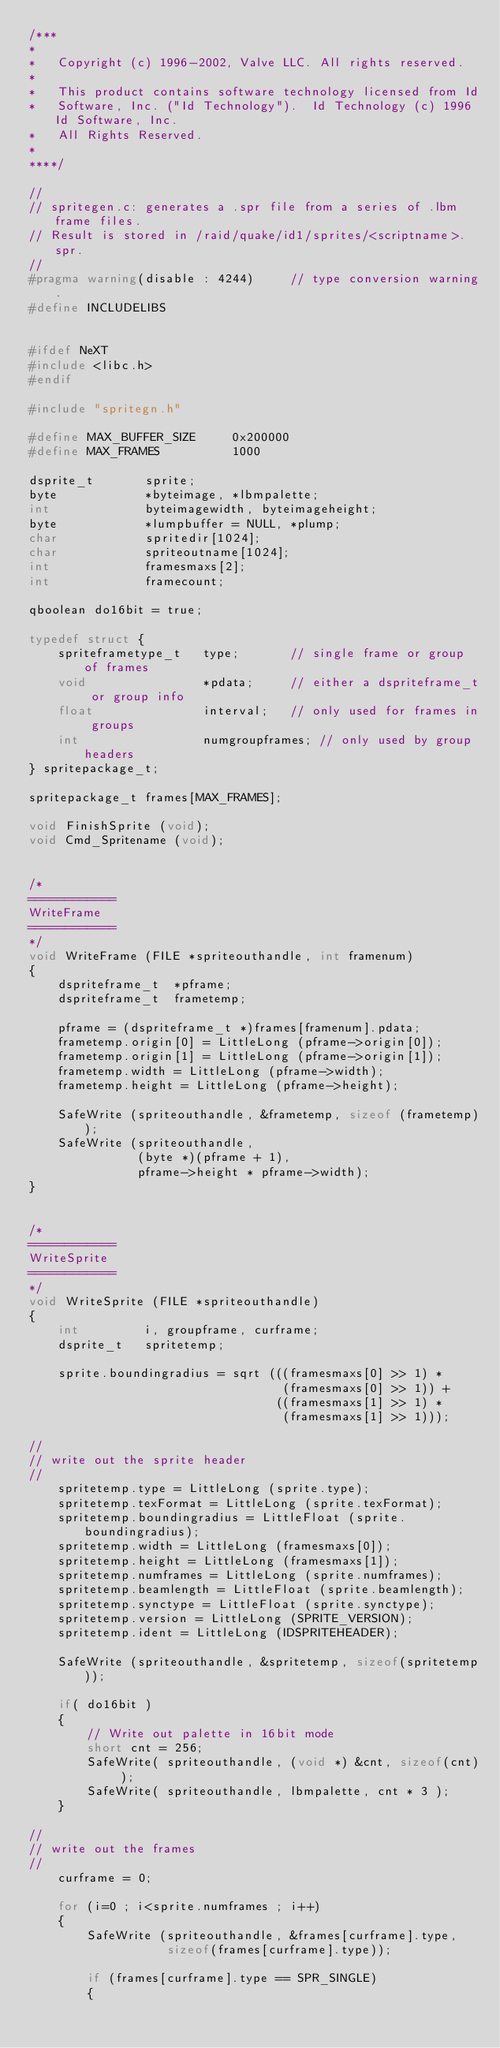<code> <loc_0><loc_0><loc_500><loc_500><_C_>/***
*
*	Copyright (c) 1996-2002, Valve LLC. All rights reserved.
*	
*	This product contains software technology licensed from Id 
*	Software, Inc. ("Id Technology").  Id Technology (c) 1996 Id Software, Inc. 
*	All Rights Reserved.
*
****/

//
// spritegen.c: generates a .spr file from a series of .lbm frame files.
// Result is stored in /raid/quake/id1/sprites/<scriptname>.spr.
//
#pragma warning(disable : 4244)     // type conversion warning.
#define INCLUDELIBS


#ifdef NeXT
#include <libc.h>
#endif

#include "spritegn.h"

#define MAX_BUFFER_SIZE		0x200000
#define MAX_FRAMES			1000

dsprite_t		sprite;
byte			*byteimage, *lbmpalette;
int				byteimagewidth, byteimageheight;
byte			*lumpbuffer = NULL, *plump;
char			spritedir[1024];
char			spriteoutname[1024];
int				framesmaxs[2];
int				framecount;

qboolean do16bit = true;

typedef struct {
	spriteframetype_t	type;		// single frame or group of frames
	void				*pdata;		// either a dspriteframe_t or group info
	float				interval;	// only used for frames in groups
	int					numgroupframes;	// only used by group headers
} spritepackage_t;

spritepackage_t	frames[MAX_FRAMES];

void FinishSprite (void);
void Cmd_Spritename (void);


/*
============
WriteFrame
============
*/
void WriteFrame (FILE *spriteouthandle, int framenum)
{
	dspriteframe_t	*pframe;
	dspriteframe_t	frametemp;

	pframe = (dspriteframe_t *)frames[framenum].pdata;
	frametemp.origin[0] = LittleLong (pframe->origin[0]);
	frametemp.origin[1] = LittleLong (pframe->origin[1]);
	frametemp.width = LittleLong (pframe->width);
	frametemp.height = LittleLong (pframe->height);

	SafeWrite (spriteouthandle, &frametemp, sizeof (frametemp));
	SafeWrite (spriteouthandle,
			   (byte *)(pframe + 1),
			   pframe->height * pframe->width);
}


/*
============
WriteSprite
============
*/
void WriteSprite (FILE *spriteouthandle)
{
	int			i, groupframe, curframe;
	dsprite_t	spritetemp;

	sprite.boundingradius = sqrt (((framesmaxs[0] >> 1) *
								   (framesmaxs[0] >> 1)) +
								  ((framesmaxs[1] >> 1) *
								   (framesmaxs[1] >> 1)));

//
// write out the sprite header
//
	spritetemp.type = LittleLong (sprite.type);
	spritetemp.texFormat = LittleLong (sprite.texFormat);
	spritetemp.boundingradius = LittleFloat (sprite.boundingradius);
	spritetemp.width = LittleLong (framesmaxs[0]);
	spritetemp.height = LittleLong (framesmaxs[1]);
	spritetemp.numframes = LittleLong (sprite.numframes);
	spritetemp.beamlength = LittleFloat (sprite.beamlength);
	spritetemp.synctype = LittleFloat (sprite.synctype);
	spritetemp.version = LittleLong (SPRITE_VERSION);
	spritetemp.ident = LittleLong (IDSPRITEHEADER);

	SafeWrite (spriteouthandle, &spritetemp, sizeof(spritetemp));

	if( do16bit )
	{
		// Write out palette in 16bit mode
		short cnt = 256;
		SafeWrite( spriteouthandle, (void *) &cnt, sizeof(cnt) );
		SafeWrite( spriteouthandle, lbmpalette, cnt * 3 );
	}

//
// write out the frames
//
	curframe = 0;

	for (i=0 ; i<sprite.numframes ; i++)
	{
		SafeWrite (spriteouthandle, &frames[curframe].type,
				   sizeof(frames[curframe].type));

		if (frames[curframe].type == SPR_SINGLE)
		{</code> 